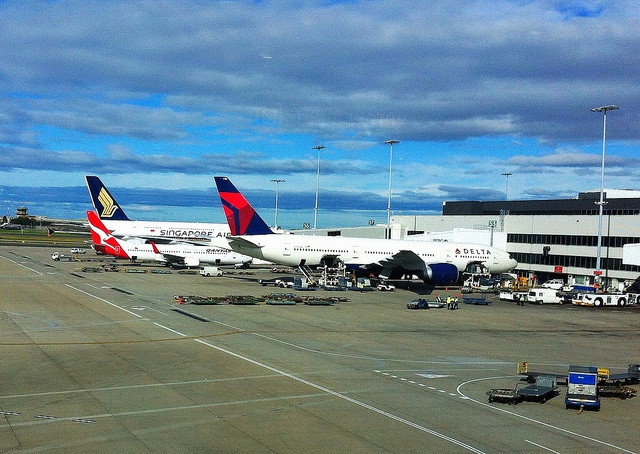Describe the objects in this image and their specific colors. I can see airplane in blue, white, black, navy, and gray tones, airplane in blue, white, red, darkgray, and gray tones, airplane in blue, white, navy, black, and darkgray tones, truck in blue, black, darkgray, darkblue, and navy tones, and truck in blue, white, black, darkgray, and gray tones in this image. 